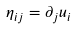<formula> <loc_0><loc_0><loc_500><loc_500>\eta _ { i j } = \partial _ { j } u _ { i } \</formula> 